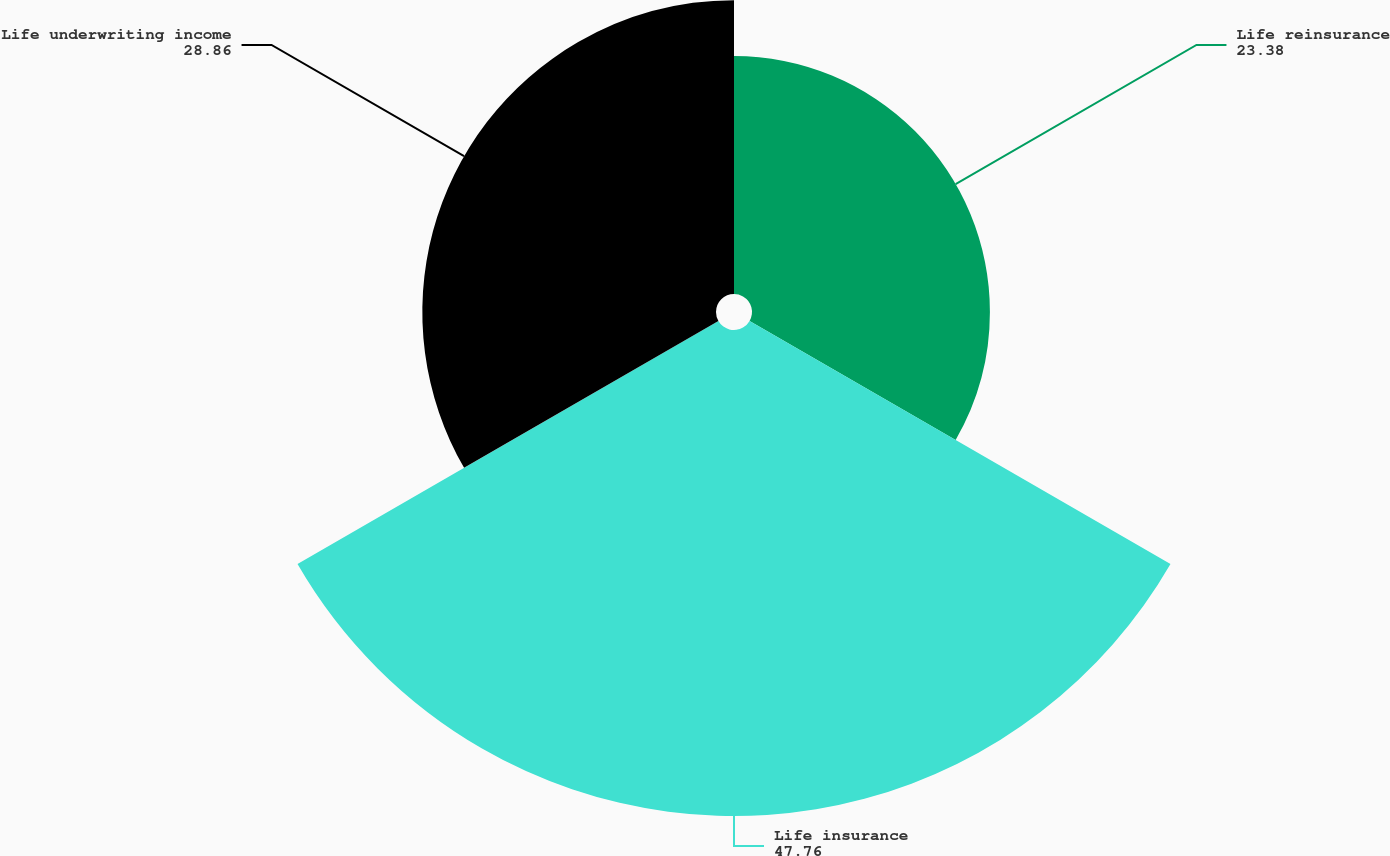Convert chart to OTSL. <chart><loc_0><loc_0><loc_500><loc_500><pie_chart><fcel>Life reinsurance<fcel>Life insurance<fcel>Life underwriting income<nl><fcel>23.38%<fcel>47.76%<fcel>28.86%<nl></chart> 